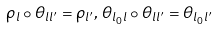Convert formula to latex. <formula><loc_0><loc_0><loc_500><loc_500>\rho _ { l } \circ \theta _ { l l ^ { \prime } } = \rho _ { l ^ { \prime } } , \, \theta _ { l _ { 0 } l } \circ \theta _ { l l ^ { \prime } } = \theta _ { l _ { 0 } l ^ { \prime } }</formula> 